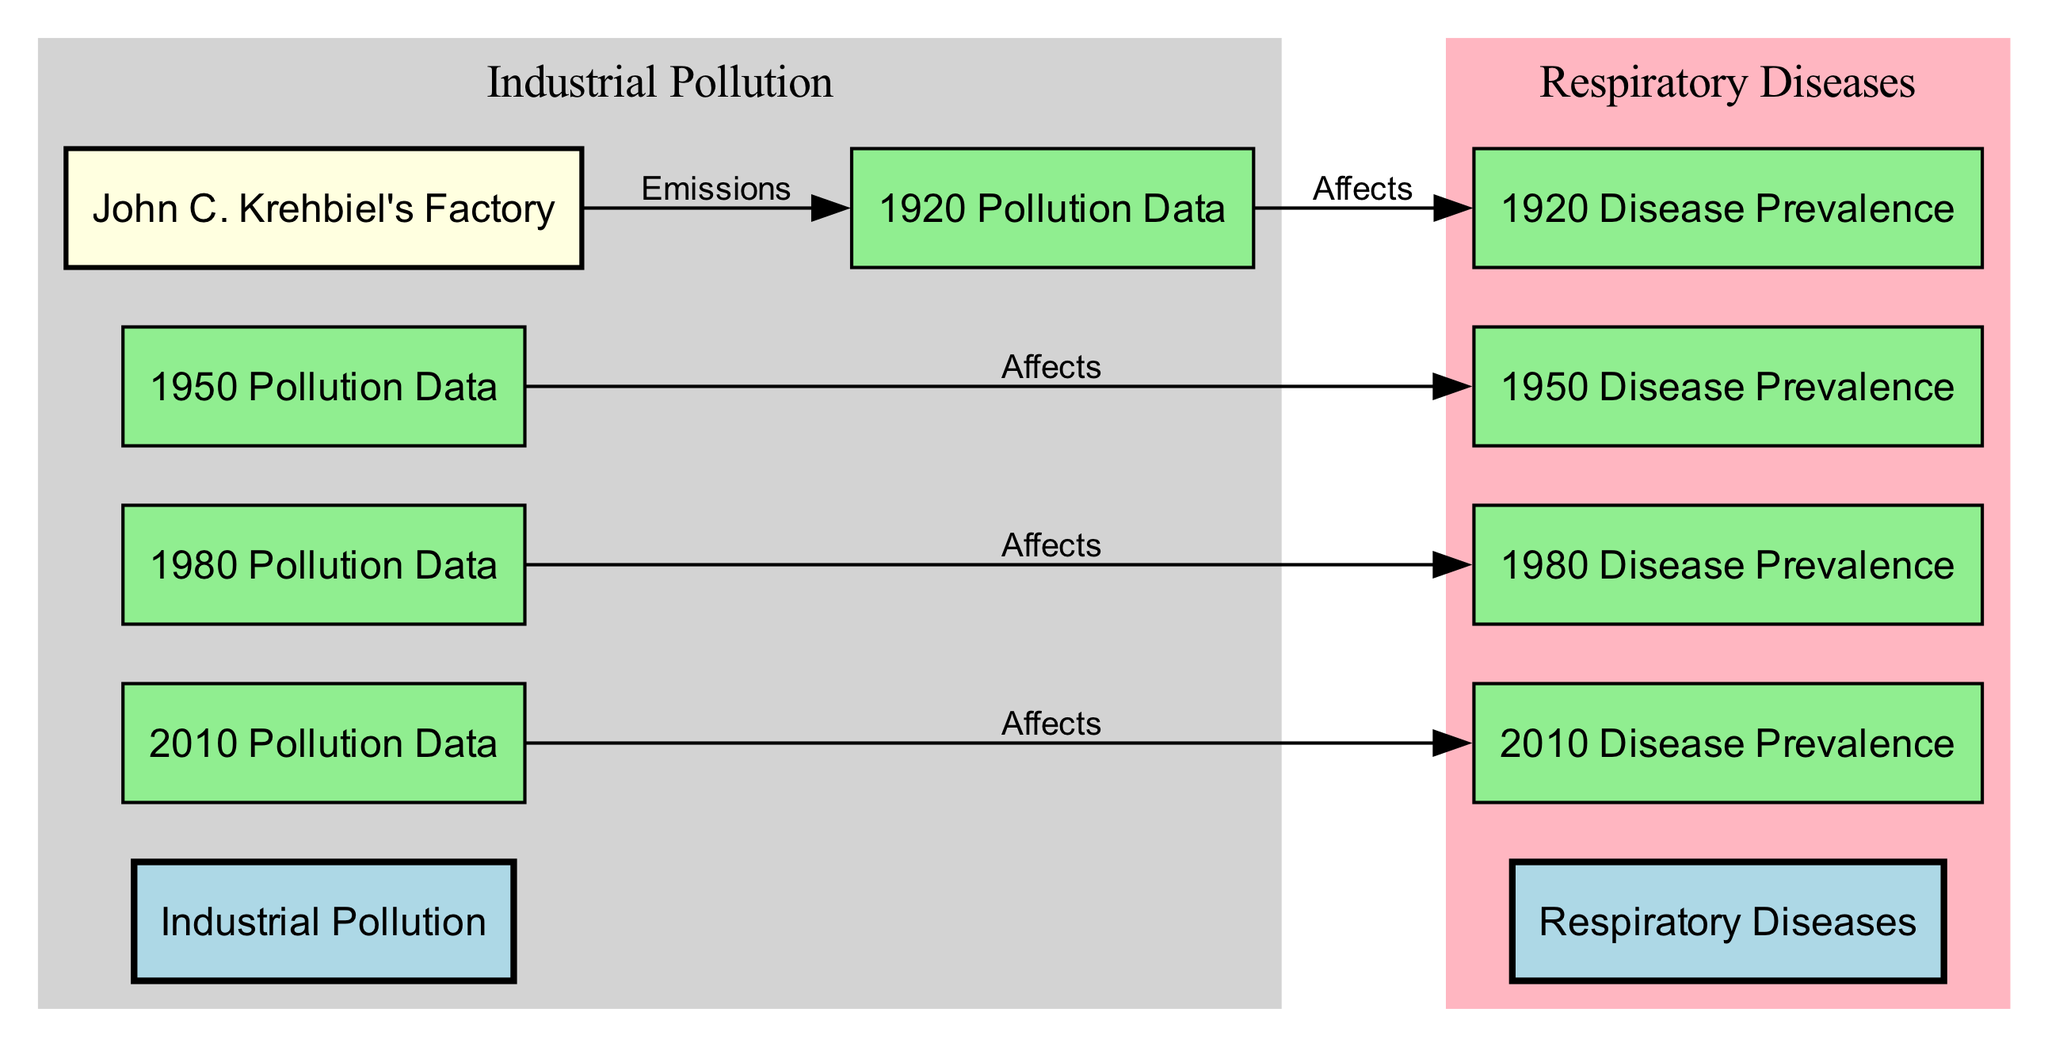What is the label of the first pollution data node in the diagram? The first pollution data node listed in the diagram is labeled "1920 Pollution Data." Since we start from the earliest period represented in the data, we can identify this by looking for the first entry in the pollution data category.
Answer: 1920 Pollution Data How many disease prevalence nodes are in the diagram? Upon reviewing the nodes in the diagram, we find that there are four disease prevalence nodes, specifically: "1920 Disease Prevalence," "1950 Disease Prevalence," "1980 Disease Prevalence," and "2010 Disease Prevalence." This allows us to count a total of four nodes related to disease prevalence.
Answer: 4 What type of relationship does "pollution_1950" have with "disease_prevalence_1950"? The relationship between "pollution_1950" and "disease_prevalence_1950" is labeled "Affects," indicating that the pollution data from 1950 has a direct impact on the prevalence of respiratory diseases in that year. This can be verified by tracing the edges connected to these nodes.
Answer: Affects Which factory is connected to the 1920 pollution data? The factory connected to the 1920 pollution data is "John C. Krehbiel's Factory." Examining the edges of the diagram reveals that this factory emits pollution that corresponds to the 1920 dataset.
Answer: John C. Krehbiel's Factory What trend can be inferred about pollution data and disease prevalence from 1920 to 2010? The trend inferred is that increased pollution data across the years seems to correlate with higher rates of disease prevalence, as seen through the connecting edges labeled "Affects." To reach this conclusion, one must analyze the pollution nodes in sequence with the disease prevalence nodes, identifying consistent relationships across multiple decades.
Answer: Increased correlation How many nodes are part of the industrial pollution category? There are five nodes classified under the industrial pollution category in the diagram: "John C. Krehbiel's Factory," "1920 Pollution Data," "1950 Pollution Data," "1980 Pollution Data," and "2010 Pollution Data." Counting these provides the total number of nodes associated with industrial pollution.
Answer: 5 Which year has the latest disease prevalence data represented in the diagram? The latest year represented in the disease prevalence data is 2010, which is identified by locating the last node in the disease prevalence category list. The chronology of the years allows us to determine which is the most recent.
Answer: 2010 What is the type of node for "John C. Krehbiel's Factory"? The type of node for "John C. Krehbiel's Factory" is an "entity." This can be verified by checking the categorization details provided for each node in the diagram.
Answer: entity 